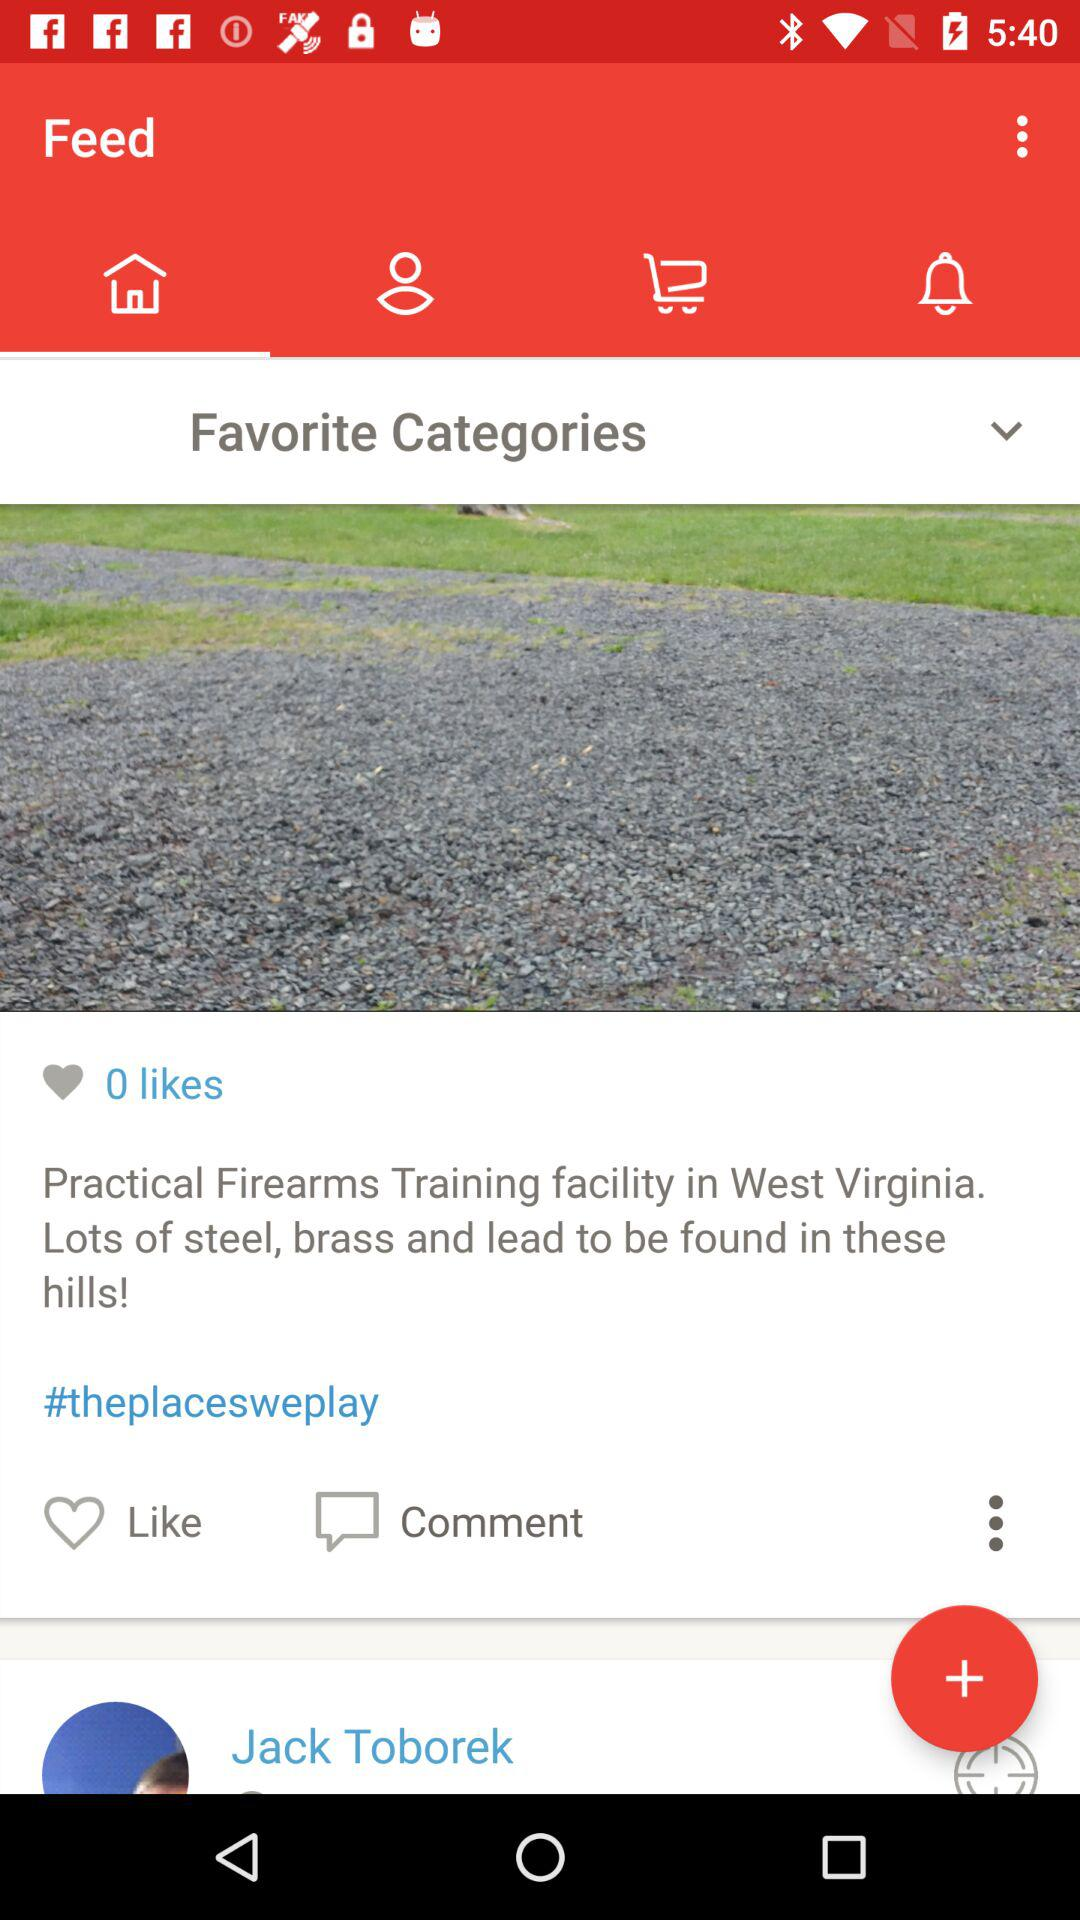How many more likes does the post have than comments?
Answer the question using a single word or phrase. 0 